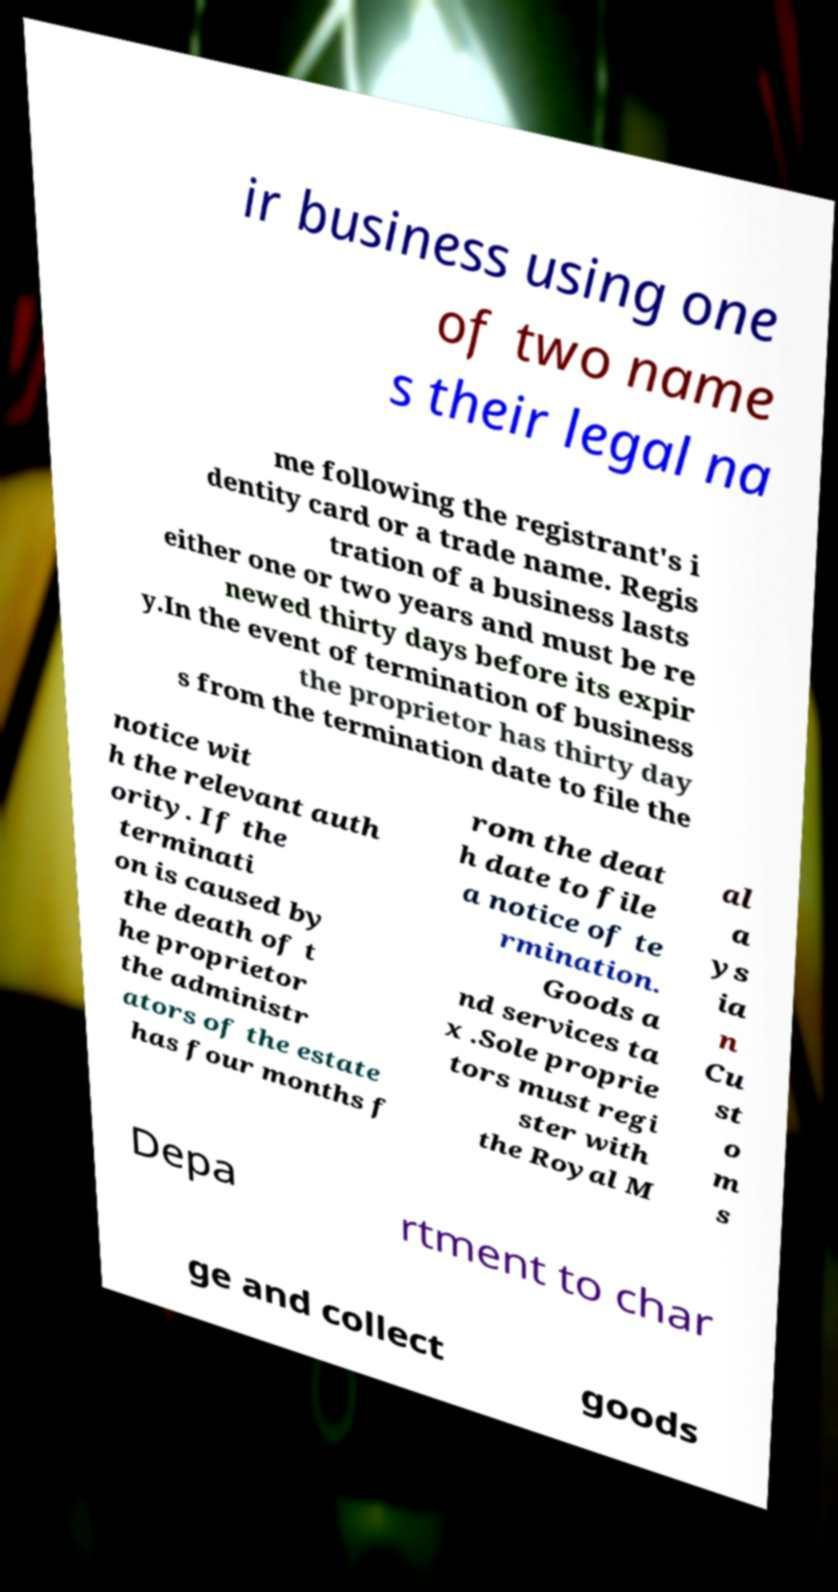Could you extract and type out the text from this image? ir business using one of two name s their legal na me following the registrant's i dentity card or a trade name. Regis tration of a business lasts either one or two years and must be re newed thirty days before its expir y.In the event of termination of business the proprietor has thirty day s from the termination date to file the notice wit h the relevant auth ority. If the terminati on is caused by the death of t he proprietor the administr ators of the estate has four months f rom the deat h date to file a notice of te rmination. Goods a nd services ta x .Sole proprie tors must regi ster with the Royal M al a ys ia n Cu st o m s Depa rtment to char ge and collect goods 